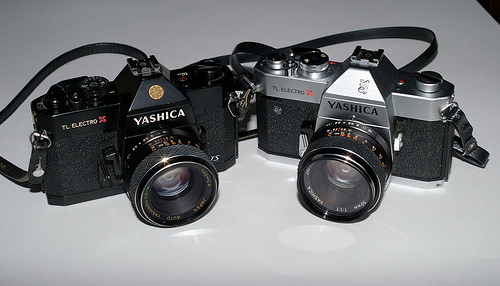<image>
Can you confirm if the camera is next to the camera? Yes. The camera is positioned adjacent to the camera, located nearby in the same general area. 